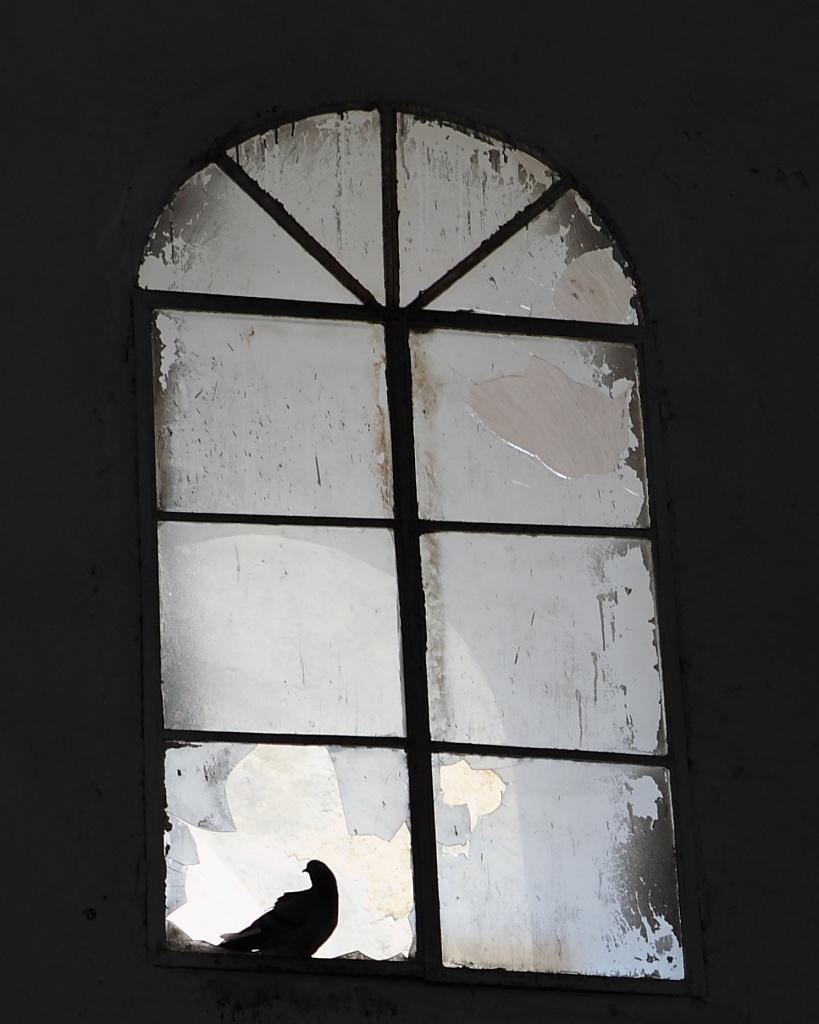Can you describe this image briefly? In this image there is a window. The window is broken. Here a bird is standing. 